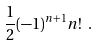<formula> <loc_0><loc_0><loc_500><loc_500>\frac { 1 } { 2 } ( - 1 ) ^ { n + 1 } n ! \ .</formula> 